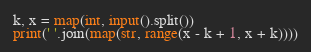Convert code to text. <code><loc_0><loc_0><loc_500><loc_500><_Python_>k, x = map(int, input().split())
print(' '.join(map(str, range(x - k + 1, x + k))))</code> 